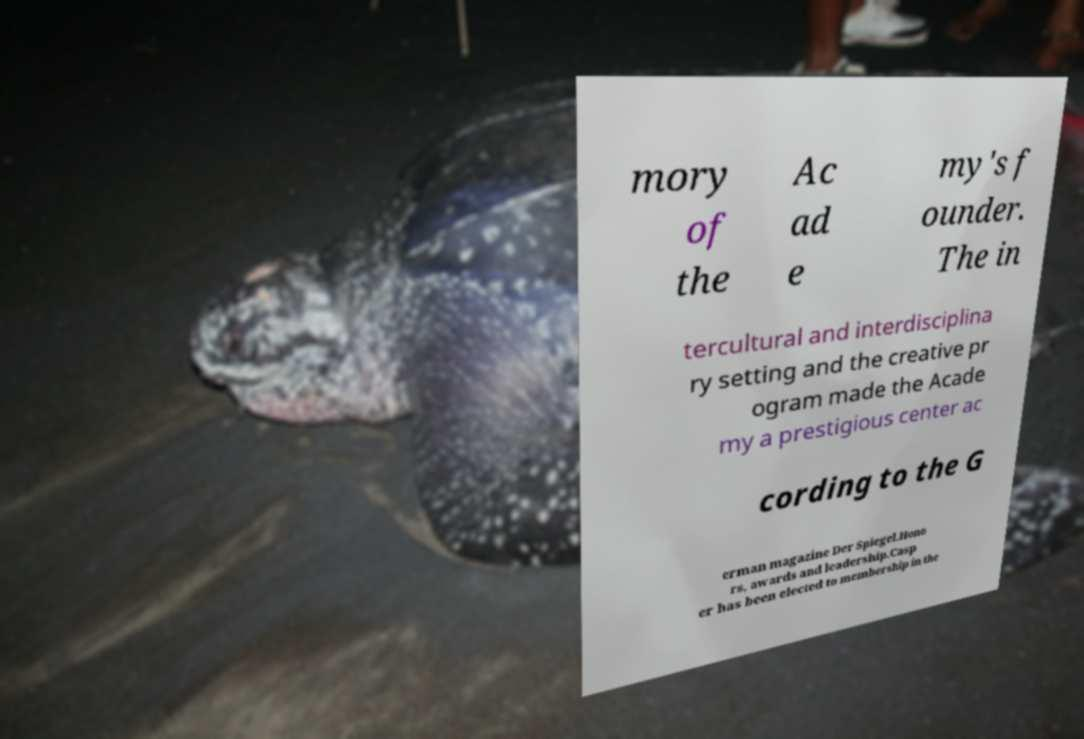Please identify and transcribe the text found in this image. mory of the Ac ad e my's f ounder. The in tercultural and interdisciplina ry setting and the creative pr ogram made the Acade my a prestigious center ac cording to the G erman magazine Der Spiegel.Hono rs, awards and leadership.Casp er has been elected to membership in the 